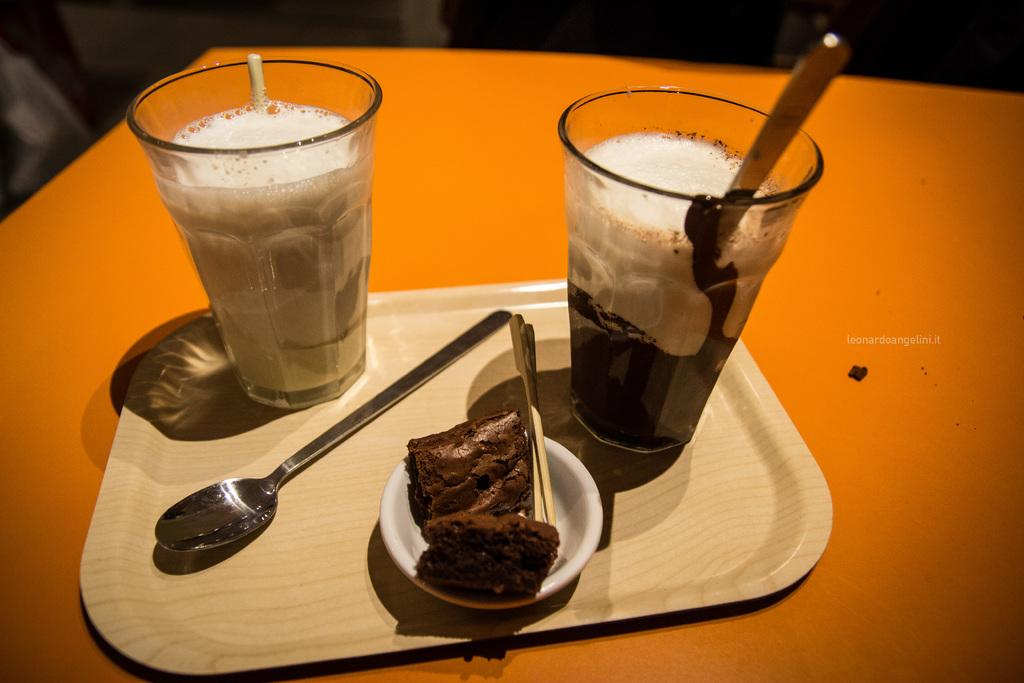What type of containers are present in the image? There are glasses with liquid in the image. What utensils can be seen in the image? There are spoons in the image. What is the main dish or food item in the image? There is food in the image. What other small items are present in the image? There are toothpicks in the image. How are the objects arranged in the image? The objects are arranged in a tray. Where is the tray located in the image? The tray is on a table. What type of nail is being used to hold the food in place in the image? There is no nail present in the image; the food is not being held in place by any nail. How many hands are visible in the image? There are no hands visible in the image. 